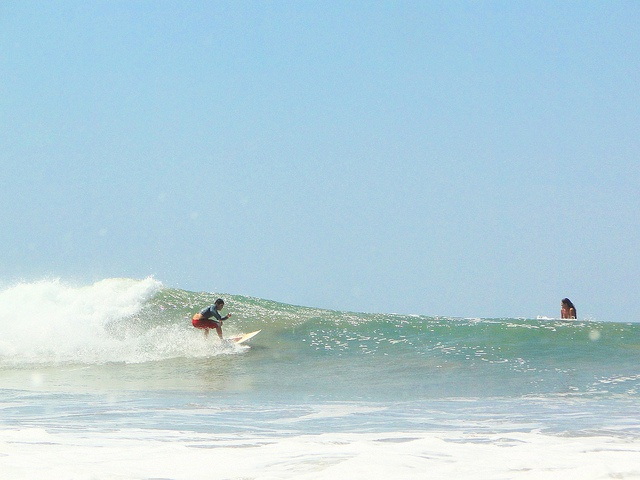Describe the objects in this image and their specific colors. I can see people in lightblue, darkgray, gray, maroon, and black tones, people in lightblue, brown, and black tones, and surfboard in lightblue, beige, darkgray, and tan tones in this image. 